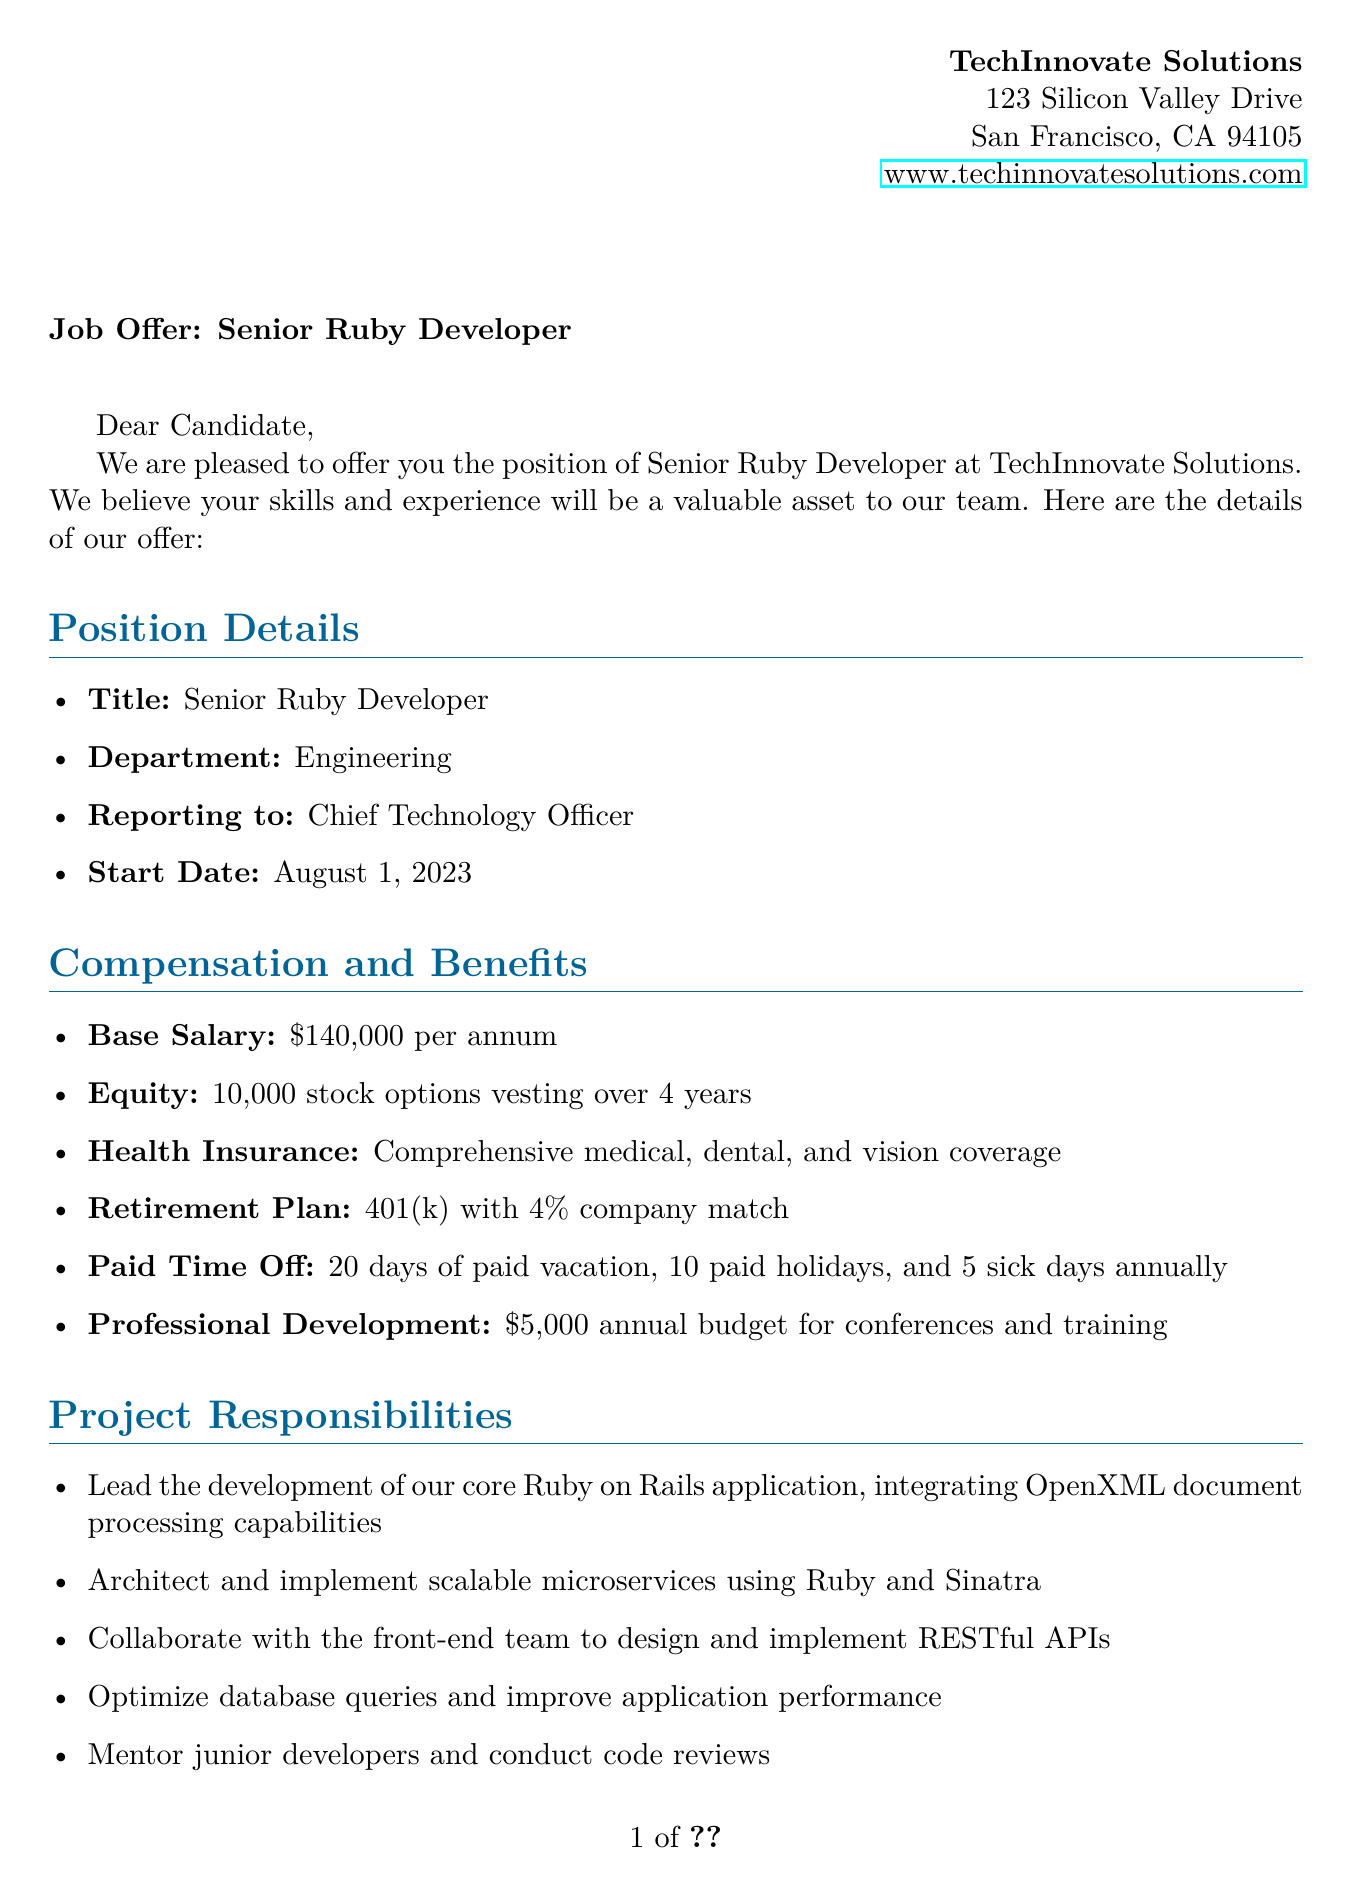what is the name of the company? The name of the company is stated at the beginning of the document, which is TechInnovate Solutions.
Answer: TechInnovate Solutions what is the base salary? The base salary is explicitly mentioned under the compensation section of the document, which is $140,000 per annum.
Answer: $140,000 per annum what is the start date for the position? The start date is specified in the position details, which states that it is August 1, 2023.
Answer: August 1, 2023 how many paid holidays are offered? The document lists the paid time off benefits, which include 10 paid holidays annually.
Answer: 10 who does the Senior Ruby Developer report to? The reporting structure is clarified in the position details, indicating the Senior Ruby Developer reports to the Chief Technology Officer.
Answer: Chief Technology Officer what is one of the current projects? The document mentions current projects, including DocuGen Pro and RubyFlow.
Answer: DocuGen Pro what type of work environment is described? The work environment is detailed under company culture, which describes it as a flexible hybrid work model with 2 days per week in-office.
Answer: Flexible hybrid work model what is the professional development budget? The document states the professional development budget offered is $5,000 annually for conferences and training.
Answer: $5,000 what is included in the additional perks? The additional perks are listed in their own section, including activities like monthly team building and gym membership reimbursement.
Answer: Monthly team building activities 